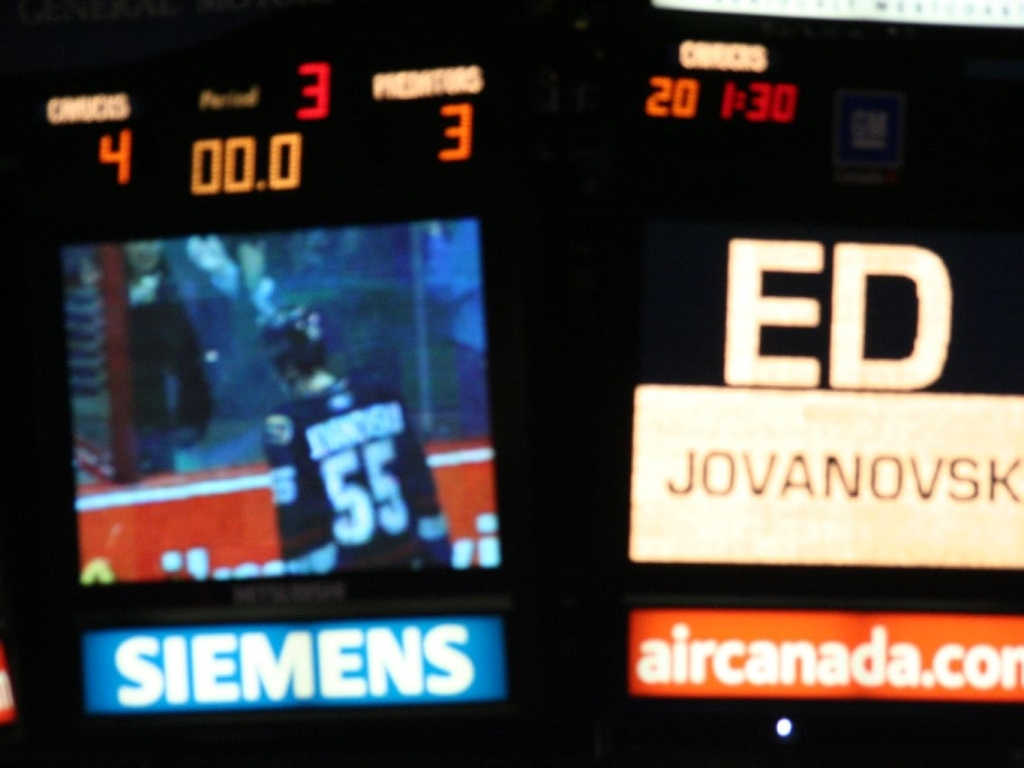What improvements could be made to the photo to convey the excitement of the sports event more effectively? To enhance the conveyance of excitement in a sports event photo, several adjustments could be beneficial: ensuring the main action is in focus, using a faster shutter speed to capture the movement sharply, a composition that includes the crowd's reaction or players' expressions, better framing to encapsulate the energy of the game, and perhaps capturing the moment when a goal is scored or a critical play is made to reflect the peak excitement of the event. And in terms of post-processing adjustments? For post-processing, increasing contrast and clarity can help make the subjects stand out more. Cropping could be employed to place the focus more on the area of interest. Color correction to enhance the ice's cool tones might intensify the feel of the hockey environment. Highlighting motion, such as a player's swift movement or the crowd's cheering, by selectively blurring the background, may also add dynamism to the photo. 